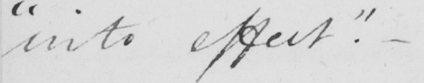What does this handwritten line say? " into effect "  .  _ 